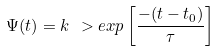<formula> <loc_0><loc_0><loc_500><loc_500>\Psi ( t ) = k \ > e x p \left [ \frac { - ( t - t _ { 0 } ) } { \tau } \right ]</formula> 